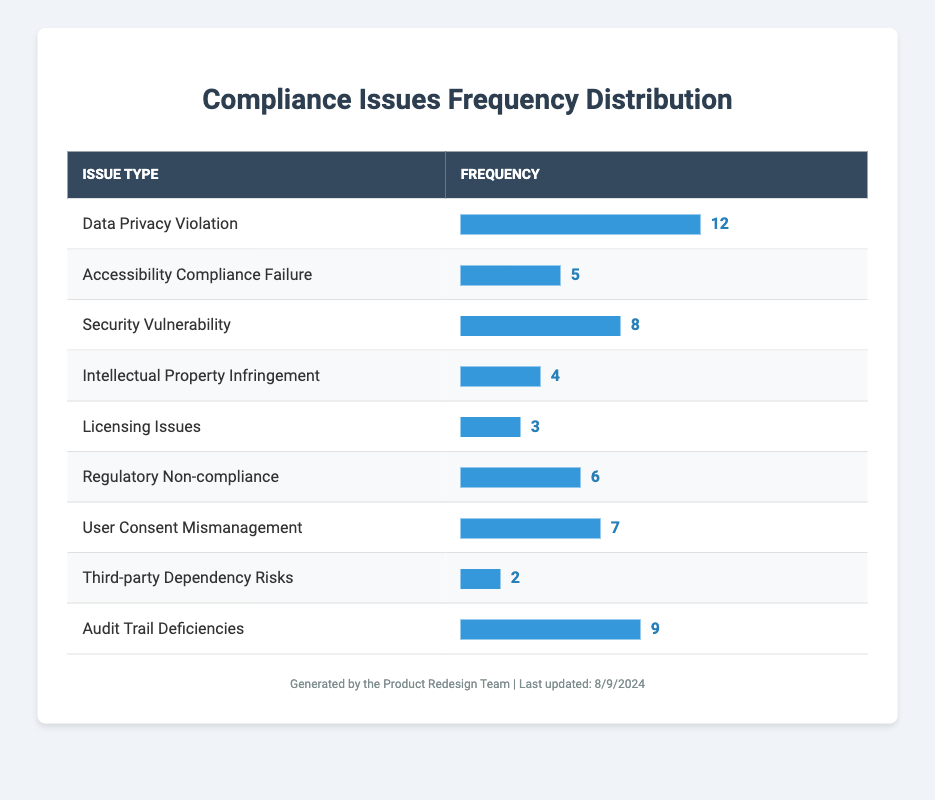What is the most frequent compliance-related issue identified during product testing? The table shows the issue types along with their frequencies. The issue with the highest frequency is "Data Privacy Violation" with a frequency of 12.
Answer: Data Privacy Violation How many compliance-related issues have a frequency of 6 or greater? By observing the frequencies listed, the following issue types have frequencies of 6 or greater: Data Privacy Violation (12), Security Vulnerability (8), User Consent Mismanagement (7), Regulatory Non-compliance (6), and Audit Trail Deficiencies (9). This totals 5 issues.
Answer: 5 Is there a compliance-related issue with a frequency of 3? Looking through the frequency column, "Licensing Issues" has a frequency of 3. Thus, the statement is true.
Answer: Yes What is the total frequency of all compliance-related issues? To find the total frequency, we add all the individual frequencies together: 12 + 5 + 8 + 4 + 3 + 6 + 7 + 2 + 9 = 56. Thus, the total frequency is 56.
Answer: 56 Which compliance-related issue has the lowest frequency, and what is that frequency? From the table, "Third-party Dependency Risks" has the lowest frequency with a count of 2.
Answer: Third-party Dependency Risks, 2 Are there more issues related to privacy violations than security vulnerabilities? "Data Privacy Violation" has a frequency of 12 while "Security Vulnerability" has a frequency of 8. Since 12 is greater than 8, there are indeed more issues related to privacy violations.
Answer: Yes What is the average frequency of the compliance-related issues listed? To find the average frequency, we first sum all frequencies (56) and then divide that by the number of issue types (9). Thus, the average frequency is 56/9 which equals approximately 6.22.
Answer: 6.22 How many compliance-related issues are directly related to user consent and data privacy? The issues directly related to user consent and data privacy are "Data Privacy Violation" (12) and "User Consent Mismanagement" (7), giving a total of 2 issues.
Answer: 2 Which compliance issue has a frequency of less than 5? By checking the frequencies, "Intellectual Property Infringement" (4), "Licensing Issues" (3), and "Third-party Dependency Risks" (2) are all below 5. Therefore, there are three issues.
Answer: Intellectual Property Infringement, Licensing Issues, Third-party Dependency Risks 